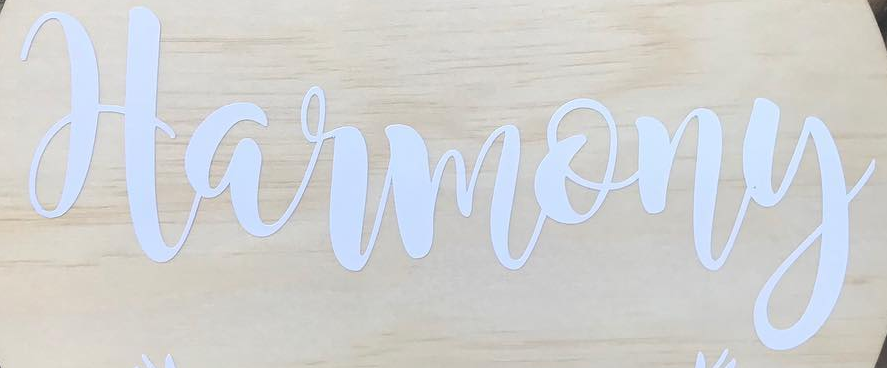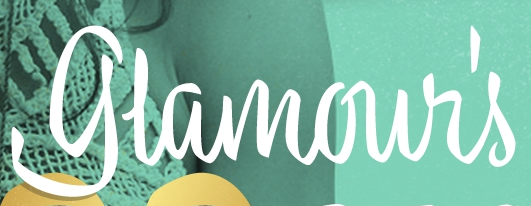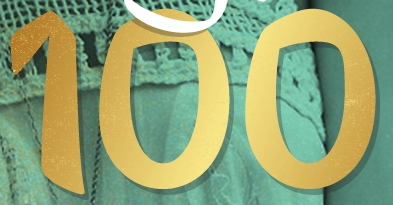What words are shown in these images in order, separated by a semicolon? Harmony; glamour's; 100 